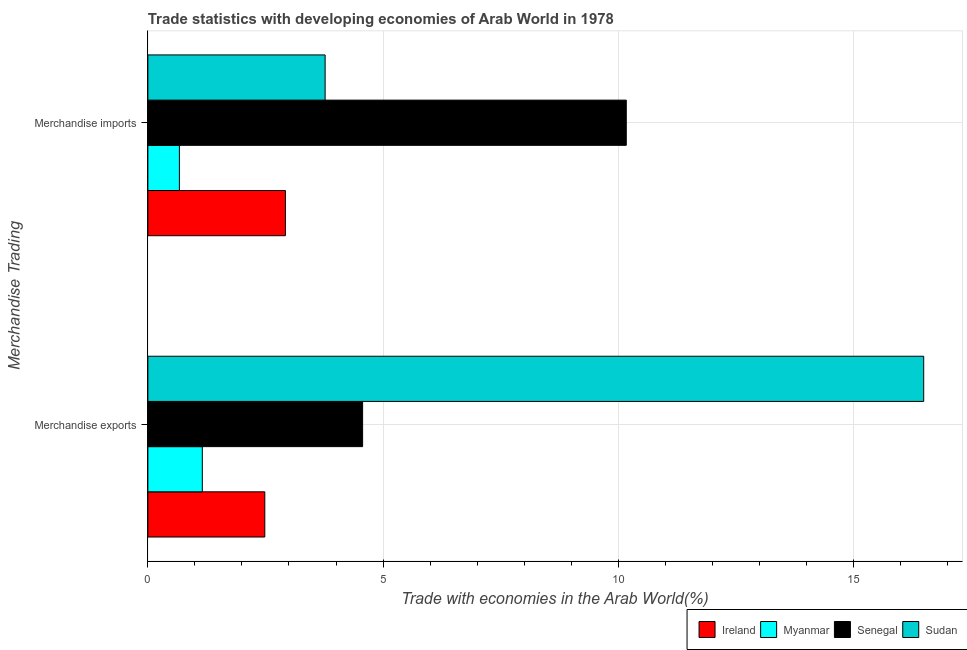How many different coloured bars are there?
Your answer should be very brief. 4. How many bars are there on the 1st tick from the bottom?
Ensure brevity in your answer.  4. What is the label of the 2nd group of bars from the top?
Provide a succinct answer. Merchandise exports. What is the merchandise exports in Senegal?
Keep it short and to the point. 4.57. Across all countries, what is the maximum merchandise exports?
Offer a terse response. 16.49. Across all countries, what is the minimum merchandise imports?
Make the answer very short. 0.67. In which country was the merchandise exports maximum?
Offer a terse response. Sudan. In which country was the merchandise exports minimum?
Offer a very short reply. Myanmar. What is the total merchandise exports in the graph?
Give a very brief answer. 24.7. What is the difference between the merchandise exports in Ireland and that in Sudan?
Offer a very short reply. -14.01. What is the difference between the merchandise imports in Senegal and the merchandise exports in Sudan?
Your answer should be compact. -6.32. What is the average merchandise imports per country?
Provide a short and direct response. 4.38. What is the difference between the merchandise imports and merchandise exports in Senegal?
Offer a terse response. 5.61. In how many countries, is the merchandise imports greater than 6 %?
Provide a succinct answer. 1. What is the ratio of the merchandise imports in Senegal to that in Ireland?
Make the answer very short. 3.48. In how many countries, is the merchandise imports greater than the average merchandise imports taken over all countries?
Offer a terse response. 1. What does the 2nd bar from the top in Merchandise exports represents?
Provide a short and direct response. Senegal. What does the 1st bar from the bottom in Merchandise exports represents?
Ensure brevity in your answer.  Ireland. How many bars are there?
Ensure brevity in your answer.  8. Are all the bars in the graph horizontal?
Your answer should be very brief. Yes. Does the graph contain any zero values?
Offer a terse response. No. How many legend labels are there?
Your response must be concise. 4. How are the legend labels stacked?
Ensure brevity in your answer.  Horizontal. What is the title of the graph?
Offer a terse response. Trade statistics with developing economies of Arab World in 1978. What is the label or title of the X-axis?
Offer a very short reply. Trade with economies in the Arab World(%). What is the label or title of the Y-axis?
Your answer should be very brief. Merchandise Trading. What is the Trade with economies in the Arab World(%) of Ireland in Merchandise exports?
Make the answer very short. 2.49. What is the Trade with economies in the Arab World(%) in Myanmar in Merchandise exports?
Keep it short and to the point. 1.16. What is the Trade with economies in the Arab World(%) in Senegal in Merchandise exports?
Provide a short and direct response. 4.57. What is the Trade with economies in the Arab World(%) in Sudan in Merchandise exports?
Offer a terse response. 16.49. What is the Trade with economies in the Arab World(%) in Ireland in Merchandise imports?
Your answer should be compact. 2.92. What is the Trade with economies in the Arab World(%) of Myanmar in Merchandise imports?
Make the answer very short. 0.67. What is the Trade with economies in the Arab World(%) in Senegal in Merchandise imports?
Make the answer very short. 10.17. What is the Trade with economies in the Arab World(%) of Sudan in Merchandise imports?
Keep it short and to the point. 3.77. Across all Merchandise Trading, what is the maximum Trade with economies in the Arab World(%) in Ireland?
Offer a very short reply. 2.92. Across all Merchandise Trading, what is the maximum Trade with economies in the Arab World(%) of Myanmar?
Give a very brief answer. 1.16. Across all Merchandise Trading, what is the maximum Trade with economies in the Arab World(%) of Senegal?
Your answer should be compact. 10.17. Across all Merchandise Trading, what is the maximum Trade with economies in the Arab World(%) of Sudan?
Ensure brevity in your answer.  16.49. Across all Merchandise Trading, what is the minimum Trade with economies in the Arab World(%) in Ireland?
Offer a terse response. 2.49. Across all Merchandise Trading, what is the minimum Trade with economies in the Arab World(%) in Myanmar?
Provide a short and direct response. 0.67. Across all Merchandise Trading, what is the minimum Trade with economies in the Arab World(%) of Senegal?
Your answer should be compact. 4.57. Across all Merchandise Trading, what is the minimum Trade with economies in the Arab World(%) in Sudan?
Make the answer very short. 3.77. What is the total Trade with economies in the Arab World(%) of Ireland in the graph?
Provide a short and direct response. 5.41. What is the total Trade with economies in the Arab World(%) of Myanmar in the graph?
Make the answer very short. 1.83. What is the total Trade with economies in the Arab World(%) of Senegal in the graph?
Make the answer very short. 14.74. What is the total Trade with economies in the Arab World(%) in Sudan in the graph?
Provide a succinct answer. 20.26. What is the difference between the Trade with economies in the Arab World(%) in Ireland in Merchandise exports and that in Merchandise imports?
Keep it short and to the point. -0.44. What is the difference between the Trade with economies in the Arab World(%) in Myanmar in Merchandise exports and that in Merchandise imports?
Your response must be concise. 0.49. What is the difference between the Trade with economies in the Arab World(%) of Senegal in Merchandise exports and that in Merchandise imports?
Provide a succinct answer. -5.61. What is the difference between the Trade with economies in the Arab World(%) of Sudan in Merchandise exports and that in Merchandise imports?
Ensure brevity in your answer.  12.73. What is the difference between the Trade with economies in the Arab World(%) in Ireland in Merchandise exports and the Trade with economies in the Arab World(%) in Myanmar in Merchandise imports?
Give a very brief answer. 1.82. What is the difference between the Trade with economies in the Arab World(%) of Ireland in Merchandise exports and the Trade with economies in the Arab World(%) of Senegal in Merchandise imports?
Make the answer very short. -7.68. What is the difference between the Trade with economies in the Arab World(%) of Ireland in Merchandise exports and the Trade with economies in the Arab World(%) of Sudan in Merchandise imports?
Your answer should be very brief. -1.28. What is the difference between the Trade with economies in the Arab World(%) of Myanmar in Merchandise exports and the Trade with economies in the Arab World(%) of Senegal in Merchandise imports?
Keep it short and to the point. -9.01. What is the difference between the Trade with economies in the Arab World(%) in Myanmar in Merchandise exports and the Trade with economies in the Arab World(%) in Sudan in Merchandise imports?
Your response must be concise. -2.61. What is the difference between the Trade with economies in the Arab World(%) in Senegal in Merchandise exports and the Trade with economies in the Arab World(%) in Sudan in Merchandise imports?
Provide a short and direct response. 0.8. What is the average Trade with economies in the Arab World(%) of Ireland per Merchandise Trading?
Keep it short and to the point. 2.71. What is the average Trade with economies in the Arab World(%) in Myanmar per Merchandise Trading?
Ensure brevity in your answer.  0.91. What is the average Trade with economies in the Arab World(%) of Senegal per Merchandise Trading?
Your answer should be compact. 7.37. What is the average Trade with economies in the Arab World(%) in Sudan per Merchandise Trading?
Ensure brevity in your answer.  10.13. What is the difference between the Trade with economies in the Arab World(%) in Ireland and Trade with economies in the Arab World(%) in Myanmar in Merchandise exports?
Your answer should be very brief. 1.33. What is the difference between the Trade with economies in the Arab World(%) in Ireland and Trade with economies in the Arab World(%) in Senegal in Merchandise exports?
Ensure brevity in your answer.  -2.08. What is the difference between the Trade with economies in the Arab World(%) of Ireland and Trade with economies in the Arab World(%) of Sudan in Merchandise exports?
Provide a succinct answer. -14.01. What is the difference between the Trade with economies in the Arab World(%) of Myanmar and Trade with economies in the Arab World(%) of Senegal in Merchandise exports?
Your answer should be compact. -3.41. What is the difference between the Trade with economies in the Arab World(%) of Myanmar and Trade with economies in the Arab World(%) of Sudan in Merchandise exports?
Give a very brief answer. -15.34. What is the difference between the Trade with economies in the Arab World(%) of Senegal and Trade with economies in the Arab World(%) of Sudan in Merchandise exports?
Keep it short and to the point. -11.93. What is the difference between the Trade with economies in the Arab World(%) of Ireland and Trade with economies in the Arab World(%) of Myanmar in Merchandise imports?
Your answer should be compact. 2.25. What is the difference between the Trade with economies in the Arab World(%) of Ireland and Trade with economies in the Arab World(%) of Senegal in Merchandise imports?
Your answer should be very brief. -7.25. What is the difference between the Trade with economies in the Arab World(%) of Ireland and Trade with economies in the Arab World(%) of Sudan in Merchandise imports?
Your answer should be very brief. -0.84. What is the difference between the Trade with economies in the Arab World(%) in Myanmar and Trade with economies in the Arab World(%) in Senegal in Merchandise imports?
Give a very brief answer. -9.5. What is the difference between the Trade with economies in the Arab World(%) in Myanmar and Trade with economies in the Arab World(%) in Sudan in Merchandise imports?
Ensure brevity in your answer.  -3.1. What is the difference between the Trade with economies in the Arab World(%) in Senegal and Trade with economies in the Arab World(%) in Sudan in Merchandise imports?
Offer a terse response. 6.4. What is the ratio of the Trade with economies in the Arab World(%) of Ireland in Merchandise exports to that in Merchandise imports?
Your answer should be very brief. 0.85. What is the ratio of the Trade with economies in the Arab World(%) in Myanmar in Merchandise exports to that in Merchandise imports?
Offer a terse response. 1.73. What is the ratio of the Trade with economies in the Arab World(%) in Senegal in Merchandise exports to that in Merchandise imports?
Give a very brief answer. 0.45. What is the ratio of the Trade with economies in the Arab World(%) of Sudan in Merchandise exports to that in Merchandise imports?
Provide a short and direct response. 4.38. What is the difference between the highest and the second highest Trade with economies in the Arab World(%) in Ireland?
Provide a short and direct response. 0.44. What is the difference between the highest and the second highest Trade with economies in the Arab World(%) of Myanmar?
Ensure brevity in your answer.  0.49. What is the difference between the highest and the second highest Trade with economies in the Arab World(%) of Senegal?
Make the answer very short. 5.61. What is the difference between the highest and the second highest Trade with economies in the Arab World(%) in Sudan?
Offer a very short reply. 12.73. What is the difference between the highest and the lowest Trade with economies in the Arab World(%) in Ireland?
Provide a succinct answer. 0.44. What is the difference between the highest and the lowest Trade with economies in the Arab World(%) in Myanmar?
Your answer should be compact. 0.49. What is the difference between the highest and the lowest Trade with economies in the Arab World(%) in Senegal?
Provide a short and direct response. 5.61. What is the difference between the highest and the lowest Trade with economies in the Arab World(%) in Sudan?
Keep it short and to the point. 12.73. 